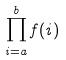<formula> <loc_0><loc_0><loc_500><loc_500>\prod _ { i = a } ^ { b } f ( i )</formula> 